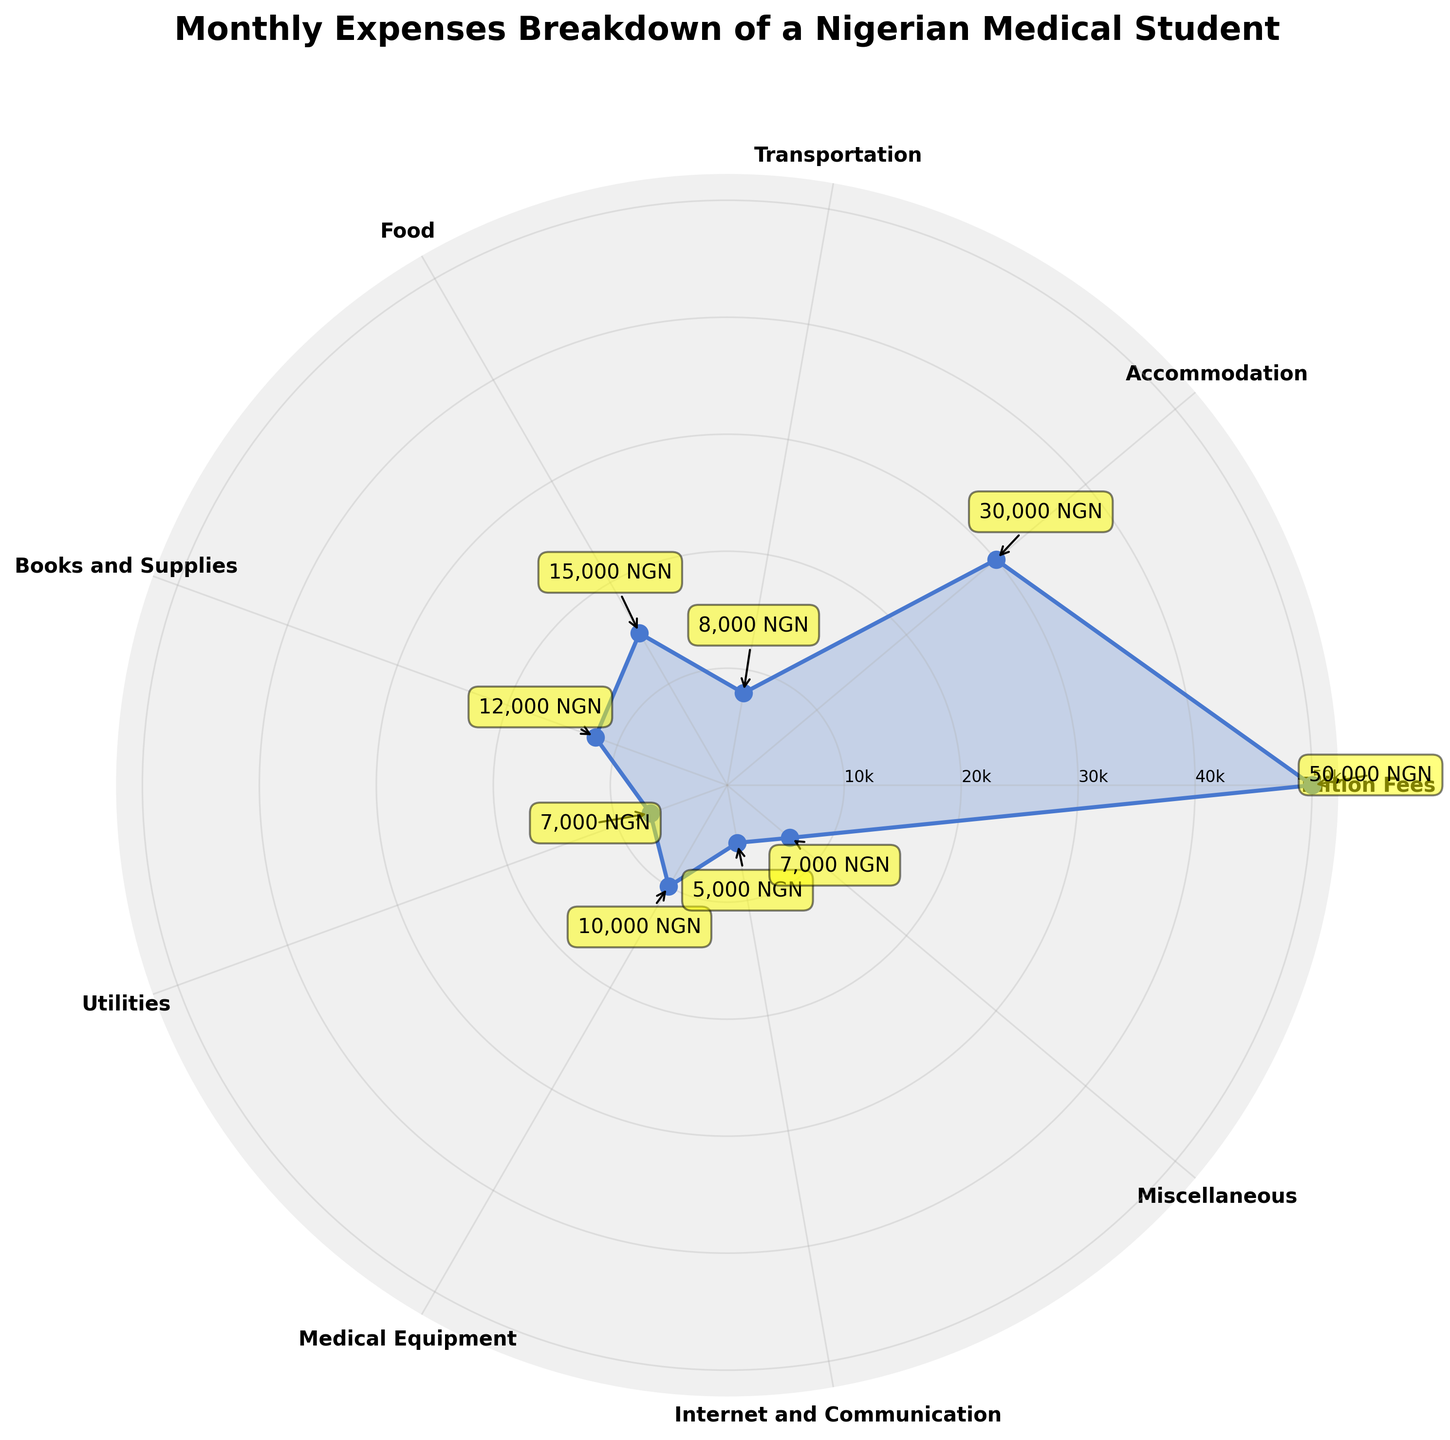What is the title of the chart? The title of the chart is usually found at the top and is used to provide a brief description of what the chart is about. In this case, it is prominently displayed at the top.
Answer: Monthly Expenses Breakdown of a Nigerian Medical Student Which category has the highest expense? To identify the highest expense, look for the segment with the greatest distance from the center. The category with the largest value should be the one that extends furthest outward.
Answer: Tuition Fees Which categories have an expense of 7000 NGN? To find the categories with an expense of 7000 NGN, observe the radial values and note down the categories that align with this value. In this case, two categories align with 7000 NGN.
Answer: Utilities, Miscellaneous What's the sum of expenses for Accommodation and Food? To get the sum, locate the values for Accommodation and Food. Add these values together. Accommodation is 30000 NGN and Food is 15000 NGN. So, 30000 + 15000 = 45000.
Answer: 45000 NGN Which expense category falls between 5000 NGN and 8000 NGN? Identify the expense categories and compare their values to see which one falls within the range of 5000 to 8000 NGN. Here, the specified category fits within the range.
Answer: Internet and Communication How many categories are displayed in the chart? Count the number of categories labeled around the outer edge of the polar chart. Each category represents one data point.
Answer: 9 Is the expense for Medical Equipment higher or lower than that for Books and Supplies? Compare the radial distance for Medical Equipment and Books and Supplies. Medical Equipment is 10000 NGN, which is less than Books and Supplies at 12000 NGN.
Answer: Lower What's the average expense of the categories listed? To find the average, sum up all the expenses and divide by the number of categories. The sum of the expenses is 50000 + 30000 + 8000 + 15000 + 12000 + 7000 + 10000 + 5000 + 7000 = 144000 NGN. The number of categories is 9. Thus, average = 144000 / 9 = 16000 NGN.
Answer: 16000 NGN Which two categories are closest in terms of expense value? Look for the two segments whose radial distances are nearest to each other. From the chart, identify Utilities and Miscellaneous both with 7000 NGN as the closest in expense value.
Answer: Utilities and Miscellaneous 